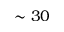<formula> <loc_0><loc_0><loc_500><loc_500>\sim 3 0</formula> 